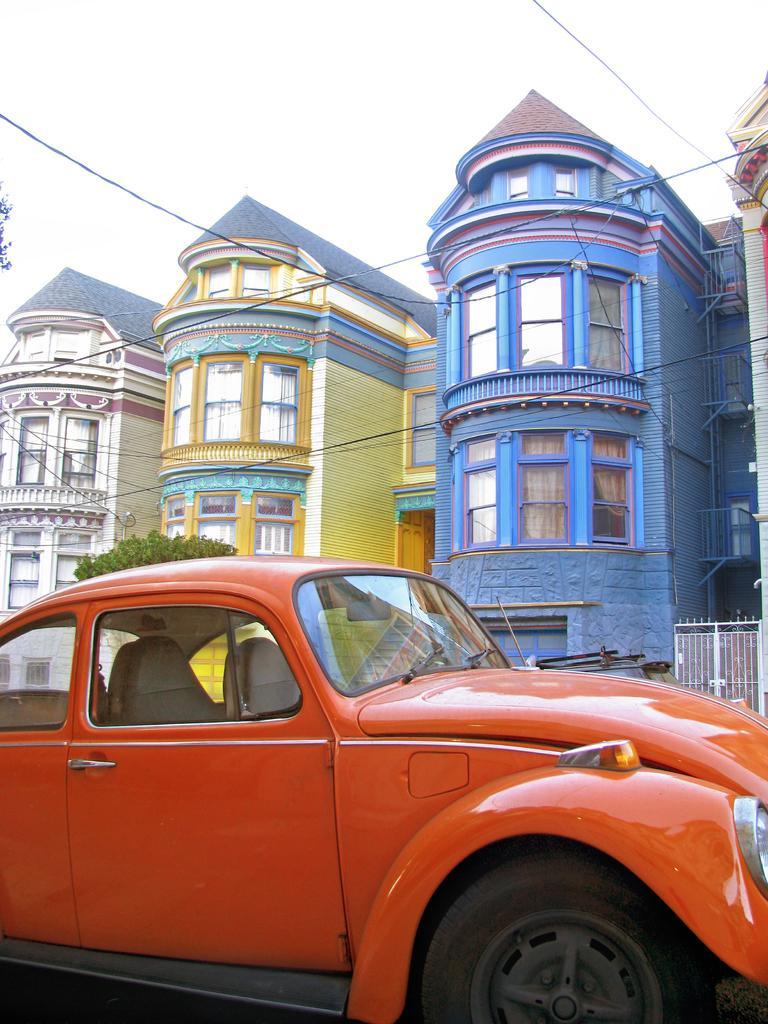Describe this image in one or two sentences. In the foreground of this image, there is an orange car. In the background, there is a white gate, few buildings, a tree, cables and the sky. 